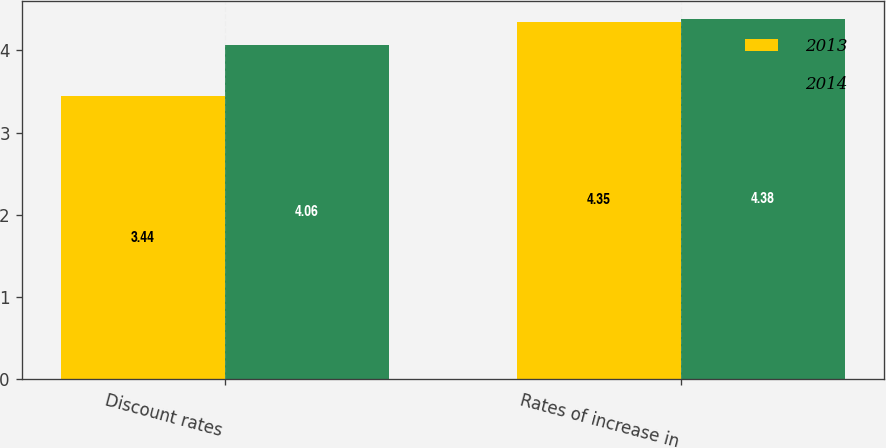Convert chart to OTSL. <chart><loc_0><loc_0><loc_500><loc_500><stacked_bar_chart><ecel><fcel>Discount rates<fcel>Rates of increase in<nl><fcel>2013<fcel>3.44<fcel>4.35<nl><fcel>2014<fcel>4.06<fcel>4.38<nl></chart> 